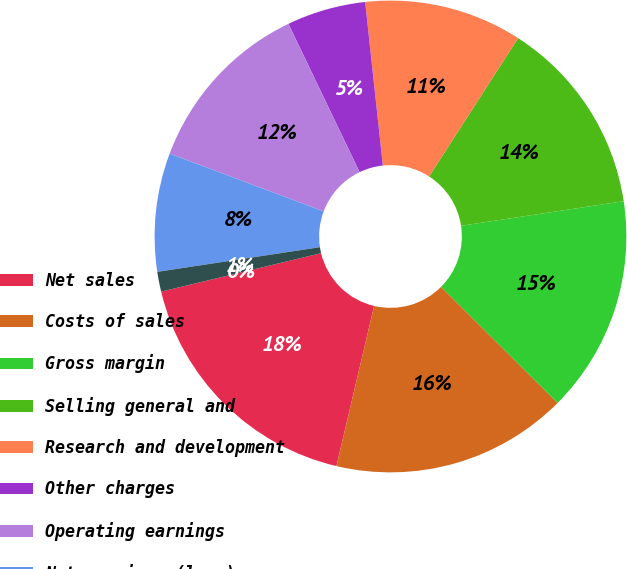<chart> <loc_0><loc_0><loc_500><loc_500><pie_chart><fcel>Net sales<fcel>Costs of sales<fcel>Gross margin<fcel>Selling general and<fcel>Research and development<fcel>Other charges<fcel>Operating earnings<fcel>Net earnings (loss)<fcel>Basic earnings per common<fcel>Diluted earnings per common<nl><fcel>17.56%<fcel>16.21%<fcel>14.86%<fcel>13.51%<fcel>10.81%<fcel>5.41%<fcel>12.16%<fcel>8.11%<fcel>1.36%<fcel>0.0%<nl></chart> 